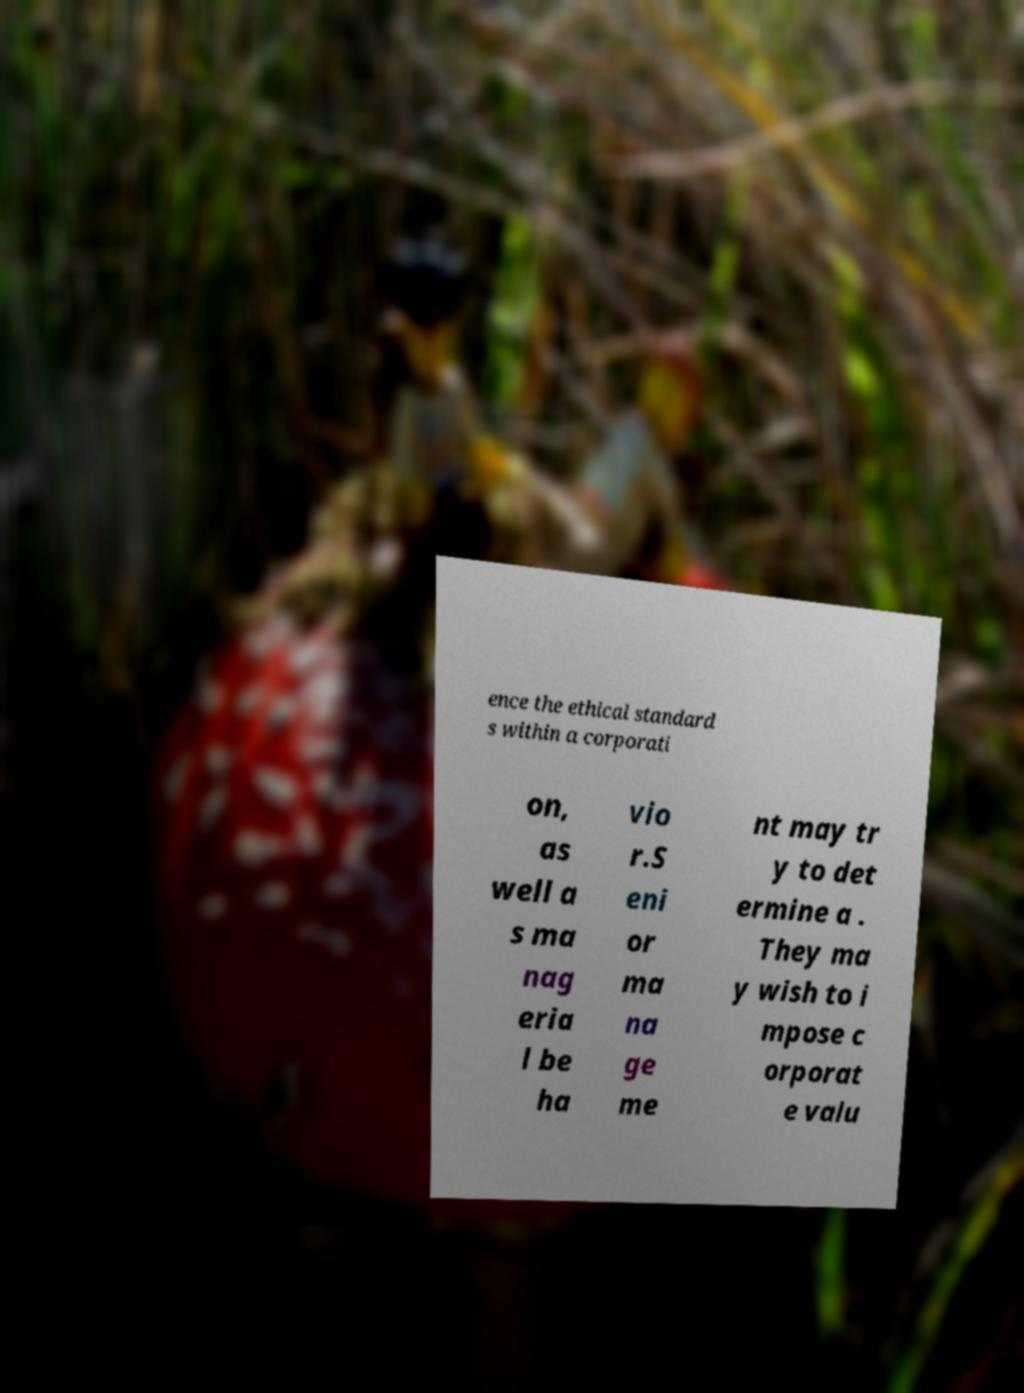Can you read and provide the text displayed in the image?This photo seems to have some interesting text. Can you extract and type it out for me? ence the ethical standard s within a corporati on, as well a s ma nag eria l be ha vio r.S eni or ma na ge me nt may tr y to det ermine a . They ma y wish to i mpose c orporat e valu 